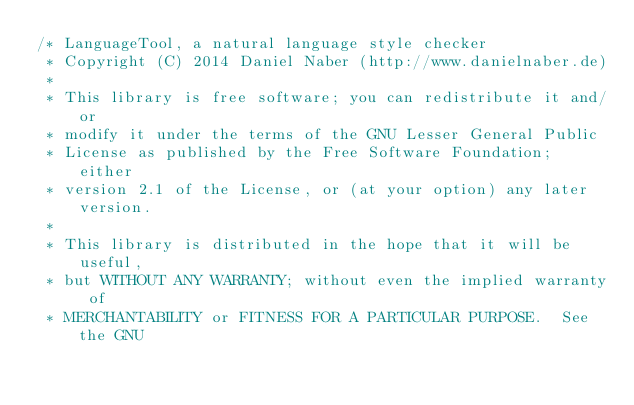<code> <loc_0><loc_0><loc_500><loc_500><_Java_>/* LanguageTool, a natural language style checker
 * Copyright (C) 2014 Daniel Naber (http://www.danielnaber.de)
 *
 * This library is free software; you can redistribute it and/or
 * modify it under the terms of the GNU Lesser General Public
 * License as published by the Free Software Foundation; either
 * version 2.1 of the License, or (at your option) any later version.
 *
 * This library is distributed in the hope that it will be useful,
 * but WITHOUT ANY WARRANTY; without even the implied warranty of
 * MERCHANTABILITY or FITNESS FOR A PARTICULAR PURPOSE.  See the GNU</code> 